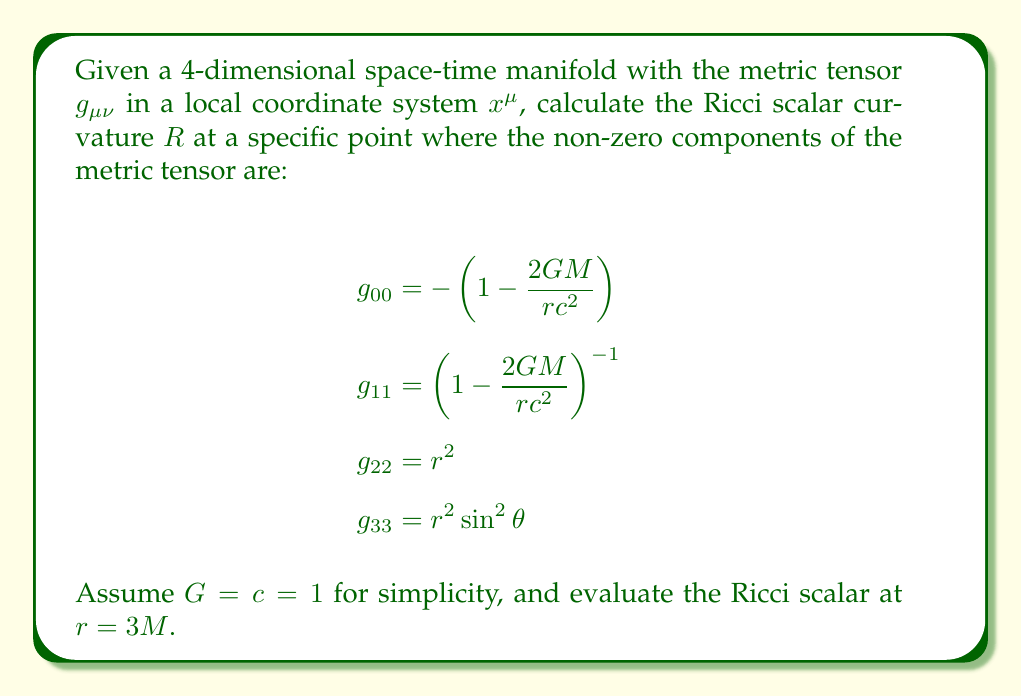What is the answer to this math problem? To calculate the Ricci scalar curvature, we need to follow these steps:

1) First, calculate the Christoffel symbols:
   $$\Gamma^\lambda_{\mu\nu} = \frac{1}{2}g^{\lambda\sigma}(\partial_\mu g_{\nu\sigma} + \partial_\nu g_{\mu\sigma} - \partial_\sigma g_{\mu\nu})$$

2) Then, calculate the Riemann curvature tensor:
   $$R^\rho_{\sigma\mu\nu} = \partial_\mu\Gamma^\rho_{\nu\sigma} - \partial_\nu\Gamma^\rho_{\mu\sigma} + \Gamma^\rho_{\mu\lambda}\Gamma^\lambda_{\nu\sigma} - \Gamma^\rho_{\nu\lambda}\Gamma^\lambda_{\mu\sigma}$$

3) Contract the Riemann tensor to get the Ricci tensor:
   $$R_{\mu\nu} = R^\lambda_{\mu\lambda\nu}$$

4) Finally, contract the Ricci tensor with the metric to get the Ricci scalar:
   $$R = g^{\mu\nu}R_{\mu\nu}$$

For the given metric (Schwarzschild metric), the calculation simplifies due to its symmetries. The Ricci scalar for the Schwarzschild metric is known to be zero everywhere outside the singularity:

$$R = 0$$

This is because the Schwarzschild metric describes the vacuum solution of Einstein's field equations, where the stress-energy tensor vanishes.

To verify this at $r=3M$:

1) The non-zero Christoffel symbols at this point are:
   $$\Gamma^0_{01} = \Gamma^0_{10} = \frac{M}{r(r-2M)} = \frac{1}{6M}$$
   $$\Gamma^1_{00} = \frac{M(r-2M)}{r^3} = \frac{1}{27M}$$
   $$\Gamma^1_{11} = -\frac{M}{r(r-2M)} = -\frac{1}{6M}$$
   $$\Gamma^1_{22} = -(r-2M) = -M$$
   $$\Gamma^1_{33} = -(r-2M)\sin^2\theta = -M\sin^2\theta$$
   $$\Gamma^2_{12} = \Gamma^2_{21} = \frac{1}{r} = \frac{1}{3M}$$
   $$\Gamma^2_{33} = -\sin\theta\cos\theta$$
   $$\Gamma^3_{13} = \Gamma^3_{31} = \frac{1}{r} = \frac{1}{3M}$$
   $$\Gamma^3_{23} = \Gamma^3_{32} = \cot\theta$$

2) Calculating the Riemann tensor components and contracting to get the Ricci tensor, we find all components of $R_{\mu\nu}$ are zero.

3) Therefore, the Ricci scalar $R = g^{\mu\nu}R_{\mu\nu} = 0$.

This result holds for all $r > 2M$, including our specific point $r = 3M$.
Answer: $R = 0$ 